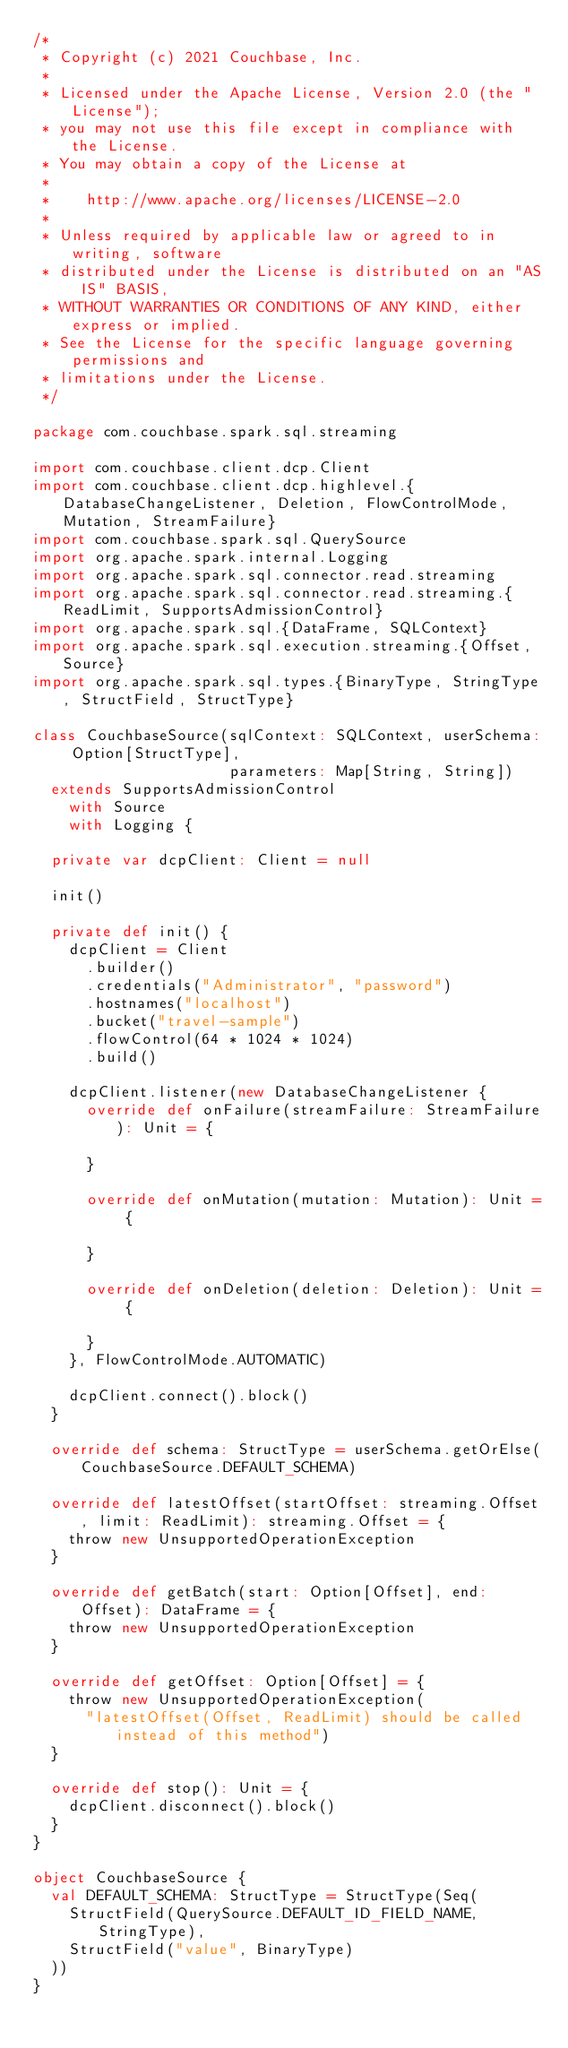<code> <loc_0><loc_0><loc_500><loc_500><_Scala_>/*
 * Copyright (c) 2021 Couchbase, Inc.
 *
 * Licensed under the Apache License, Version 2.0 (the "License");
 * you may not use this file except in compliance with the License.
 * You may obtain a copy of the License at
 *
 *    http://www.apache.org/licenses/LICENSE-2.0
 *
 * Unless required by applicable law or agreed to in writing, software
 * distributed under the License is distributed on an "AS IS" BASIS,
 * WITHOUT WARRANTIES OR CONDITIONS OF ANY KIND, either express or implied.
 * See the License for the specific language governing permissions and
 * limitations under the License.
 */

package com.couchbase.spark.sql.streaming

import com.couchbase.client.dcp.Client
import com.couchbase.client.dcp.highlevel.{DatabaseChangeListener, Deletion, FlowControlMode, Mutation, StreamFailure}
import com.couchbase.spark.sql.QuerySource
import org.apache.spark.internal.Logging
import org.apache.spark.sql.connector.read.streaming
import org.apache.spark.sql.connector.read.streaming.{ReadLimit, SupportsAdmissionControl}
import org.apache.spark.sql.{DataFrame, SQLContext}
import org.apache.spark.sql.execution.streaming.{Offset, Source}
import org.apache.spark.sql.types.{BinaryType, StringType, StructField, StructType}

class CouchbaseSource(sqlContext: SQLContext, userSchema: Option[StructType],
                      parameters: Map[String, String])
  extends SupportsAdmissionControl
    with Source
    with Logging {

  private var dcpClient: Client = null

  init()

  private def init() {
    dcpClient = Client
      .builder()
      .credentials("Administrator", "password")
      .hostnames("localhost")
      .bucket("travel-sample")
      .flowControl(64 * 1024 * 1024)
      .build()

    dcpClient.listener(new DatabaseChangeListener {
      override def onFailure(streamFailure: StreamFailure): Unit = {

      }

      override def onMutation(mutation: Mutation): Unit = {

      }

      override def onDeletion(deletion: Deletion): Unit = {

      }
    }, FlowControlMode.AUTOMATIC)

    dcpClient.connect().block()
  }

  override def schema: StructType = userSchema.getOrElse(CouchbaseSource.DEFAULT_SCHEMA)

  override def latestOffset(startOffset: streaming.Offset, limit: ReadLimit): streaming.Offset = {
    throw new UnsupportedOperationException
  }

  override def getBatch(start: Option[Offset], end: Offset): DataFrame = {
    throw new UnsupportedOperationException
  }

  override def getOffset: Option[Offset] = {
    throw new UnsupportedOperationException(
      "latestOffset(Offset, ReadLimit) should be called instead of this method")
  }

  override def stop(): Unit = {
    dcpClient.disconnect().block()
  }
}

object CouchbaseSource {
  val DEFAULT_SCHEMA: StructType = StructType(Seq(
    StructField(QuerySource.DEFAULT_ID_FIELD_NAME, StringType),
    StructField("value", BinaryType)
  ))
}</code> 